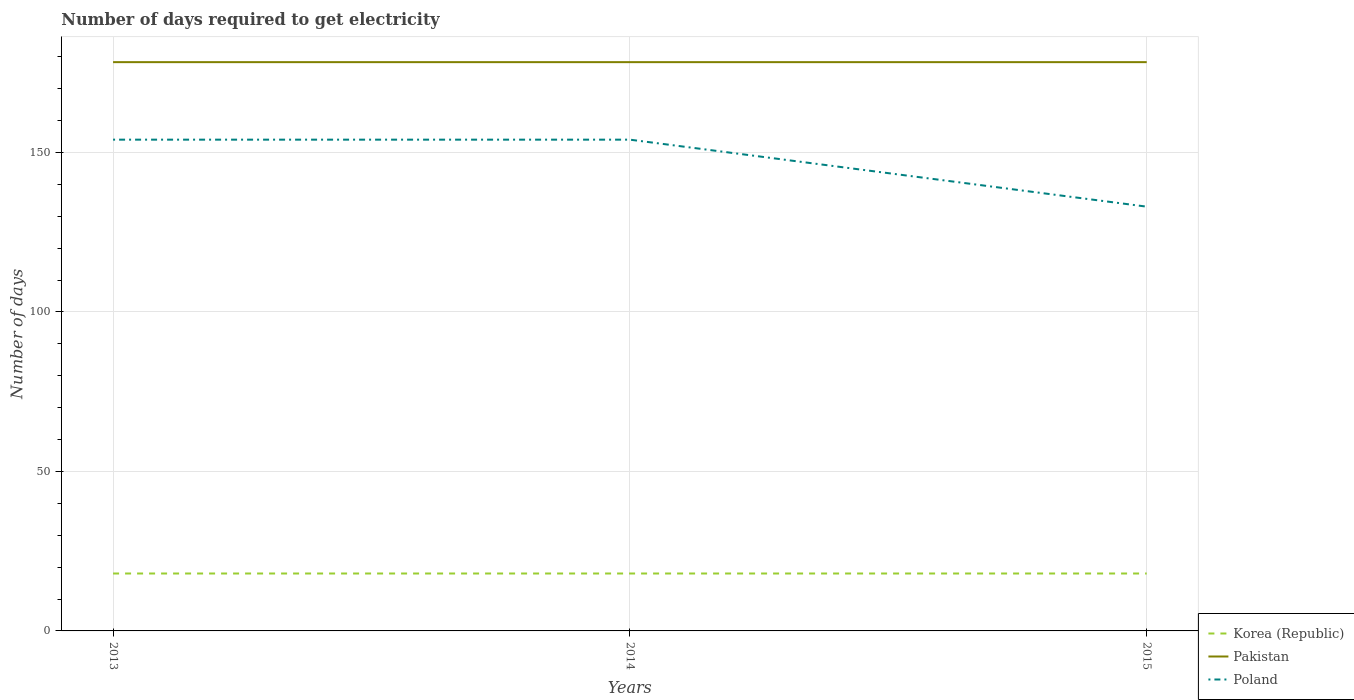How many different coloured lines are there?
Offer a very short reply. 3. Is the number of lines equal to the number of legend labels?
Your response must be concise. Yes. Across all years, what is the maximum number of days required to get electricity in in Korea (Republic)?
Make the answer very short. 18. In which year was the number of days required to get electricity in in Korea (Republic) maximum?
Provide a succinct answer. 2013. What is the difference between the highest and the lowest number of days required to get electricity in in Pakistan?
Your answer should be compact. 0. Is the number of days required to get electricity in in Poland strictly greater than the number of days required to get electricity in in Korea (Republic) over the years?
Your answer should be compact. No. How many years are there in the graph?
Provide a short and direct response. 3. What is the difference between two consecutive major ticks on the Y-axis?
Your answer should be very brief. 50. Does the graph contain grids?
Keep it short and to the point. Yes. Where does the legend appear in the graph?
Ensure brevity in your answer.  Bottom right. What is the title of the graph?
Give a very brief answer. Number of days required to get electricity. What is the label or title of the Y-axis?
Your response must be concise. Number of days. What is the Number of days of Pakistan in 2013?
Offer a terse response. 178.3. What is the Number of days of Poland in 2013?
Make the answer very short. 154. What is the Number of days of Korea (Republic) in 2014?
Make the answer very short. 18. What is the Number of days of Pakistan in 2014?
Your answer should be compact. 178.3. What is the Number of days in Poland in 2014?
Offer a terse response. 154. What is the Number of days in Korea (Republic) in 2015?
Give a very brief answer. 18. What is the Number of days of Pakistan in 2015?
Your response must be concise. 178.3. What is the Number of days in Poland in 2015?
Give a very brief answer. 133. Across all years, what is the maximum Number of days of Pakistan?
Provide a succinct answer. 178.3. Across all years, what is the maximum Number of days of Poland?
Your answer should be compact. 154. Across all years, what is the minimum Number of days in Korea (Republic)?
Provide a short and direct response. 18. Across all years, what is the minimum Number of days of Pakistan?
Make the answer very short. 178.3. Across all years, what is the minimum Number of days of Poland?
Your answer should be very brief. 133. What is the total Number of days of Pakistan in the graph?
Provide a succinct answer. 534.9. What is the total Number of days of Poland in the graph?
Offer a terse response. 441. What is the difference between the Number of days in Korea (Republic) in 2013 and that in 2014?
Give a very brief answer. 0. What is the difference between the Number of days of Pakistan in 2013 and that in 2014?
Offer a very short reply. 0. What is the difference between the Number of days in Korea (Republic) in 2013 and that in 2015?
Provide a short and direct response. 0. What is the difference between the Number of days in Poland in 2014 and that in 2015?
Provide a succinct answer. 21. What is the difference between the Number of days in Korea (Republic) in 2013 and the Number of days in Pakistan in 2014?
Offer a very short reply. -160.3. What is the difference between the Number of days in Korea (Republic) in 2013 and the Number of days in Poland in 2014?
Offer a terse response. -136. What is the difference between the Number of days in Pakistan in 2013 and the Number of days in Poland in 2014?
Your answer should be very brief. 24.3. What is the difference between the Number of days of Korea (Republic) in 2013 and the Number of days of Pakistan in 2015?
Offer a very short reply. -160.3. What is the difference between the Number of days of Korea (Republic) in 2013 and the Number of days of Poland in 2015?
Make the answer very short. -115. What is the difference between the Number of days of Pakistan in 2013 and the Number of days of Poland in 2015?
Keep it short and to the point. 45.3. What is the difference between the Number of days in Korea (Republic) in 2014 and the Number of days in Pakistan in 2015?
Give a very brief answer. -160.3. What is the difference between the Number of days of Korea (Republic) in 2014 and the Number of days of Poland in 2015?
Give a very brief answer. -115. What is the difference between the Number of days in Pakistan in 2014 and the Number of days in Poland in 2015?
Ensure brevity in your answer.  45.3. What is the average Number of days of Pakistan per year?
Your answer should be very brief. 178.3. What is the average Number of days of Poland per year?
Your answer should be compact. 147. In the year 2013, what is the difference between the Number of days in Korea (Republic) and Number of days in Pakistan?
Offer a very short reply. -160.3. In the year 2013, what is the difference between the Number of days of Korea (Republic) and Number of days of Poland?
Your answer should be compact. -136. In the year 2013, what is the difference between the Number of days in Pakistan and Number of days in Poland?
Your answer should be compact. 24.3. In the year 2014, what is the difference between the Number of days in Korea (Republic) and Number of days in Pakistan?
Your answer should be compact. -160.3. In the year 2014, what is the difference between the Number of days in Korea (Republic) and Number of days in Poland?
Offer a very short reply. -136. In the year 2014, what is the difference between the Number of days of Pakistan and Number of days of Poland?
Offer a very short reply. 24.3. In the year 2015, what is the difference between the Number of days of Korea (Republic) and Number of days of Pakistan?
Ensure brevity in your answer.  -160.3. In the year 2015, what is the difference between the Number of days of Korea (Republic) and Number of days of Poland?
Give a very brief answer. -115. In the year 2015, what is the difference between the Number of days of Pakistan and Number of days of Poland?
Offer a very short reply. 45.3. What is the ratio of the Number of days of Korea (Republic) in 2013 to that in 2014?
Your response must be concise. 1. What is the ratio of the Number of days of Poland in 2013 to that in 2014?
Provide a short and direct response. 1. What is the ratio of the Number of days of Poland in 2013 to that in 2015?
Your answer should be compact. 1.16. What is the ratio of the Number of days of Poland in 2014 to that in 2015?
Give a very brief answer. 1.16. What is the difference between the highest and the second highest Number of days of Poland?
Make the answer very short. 0. What is the difference between the highest and the lowest Number of days of Pakistan?
Ensure brevity in your answer.  0. What is the difference between the highest and the lowest Number of days in Poland?
Provide a succinct answer. 21. 